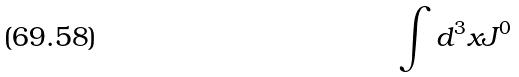<formula> <loc_0><loc_0><loc_500><loc_500>\int d ^ { 3 } x J ^ { 0 }</formula> 